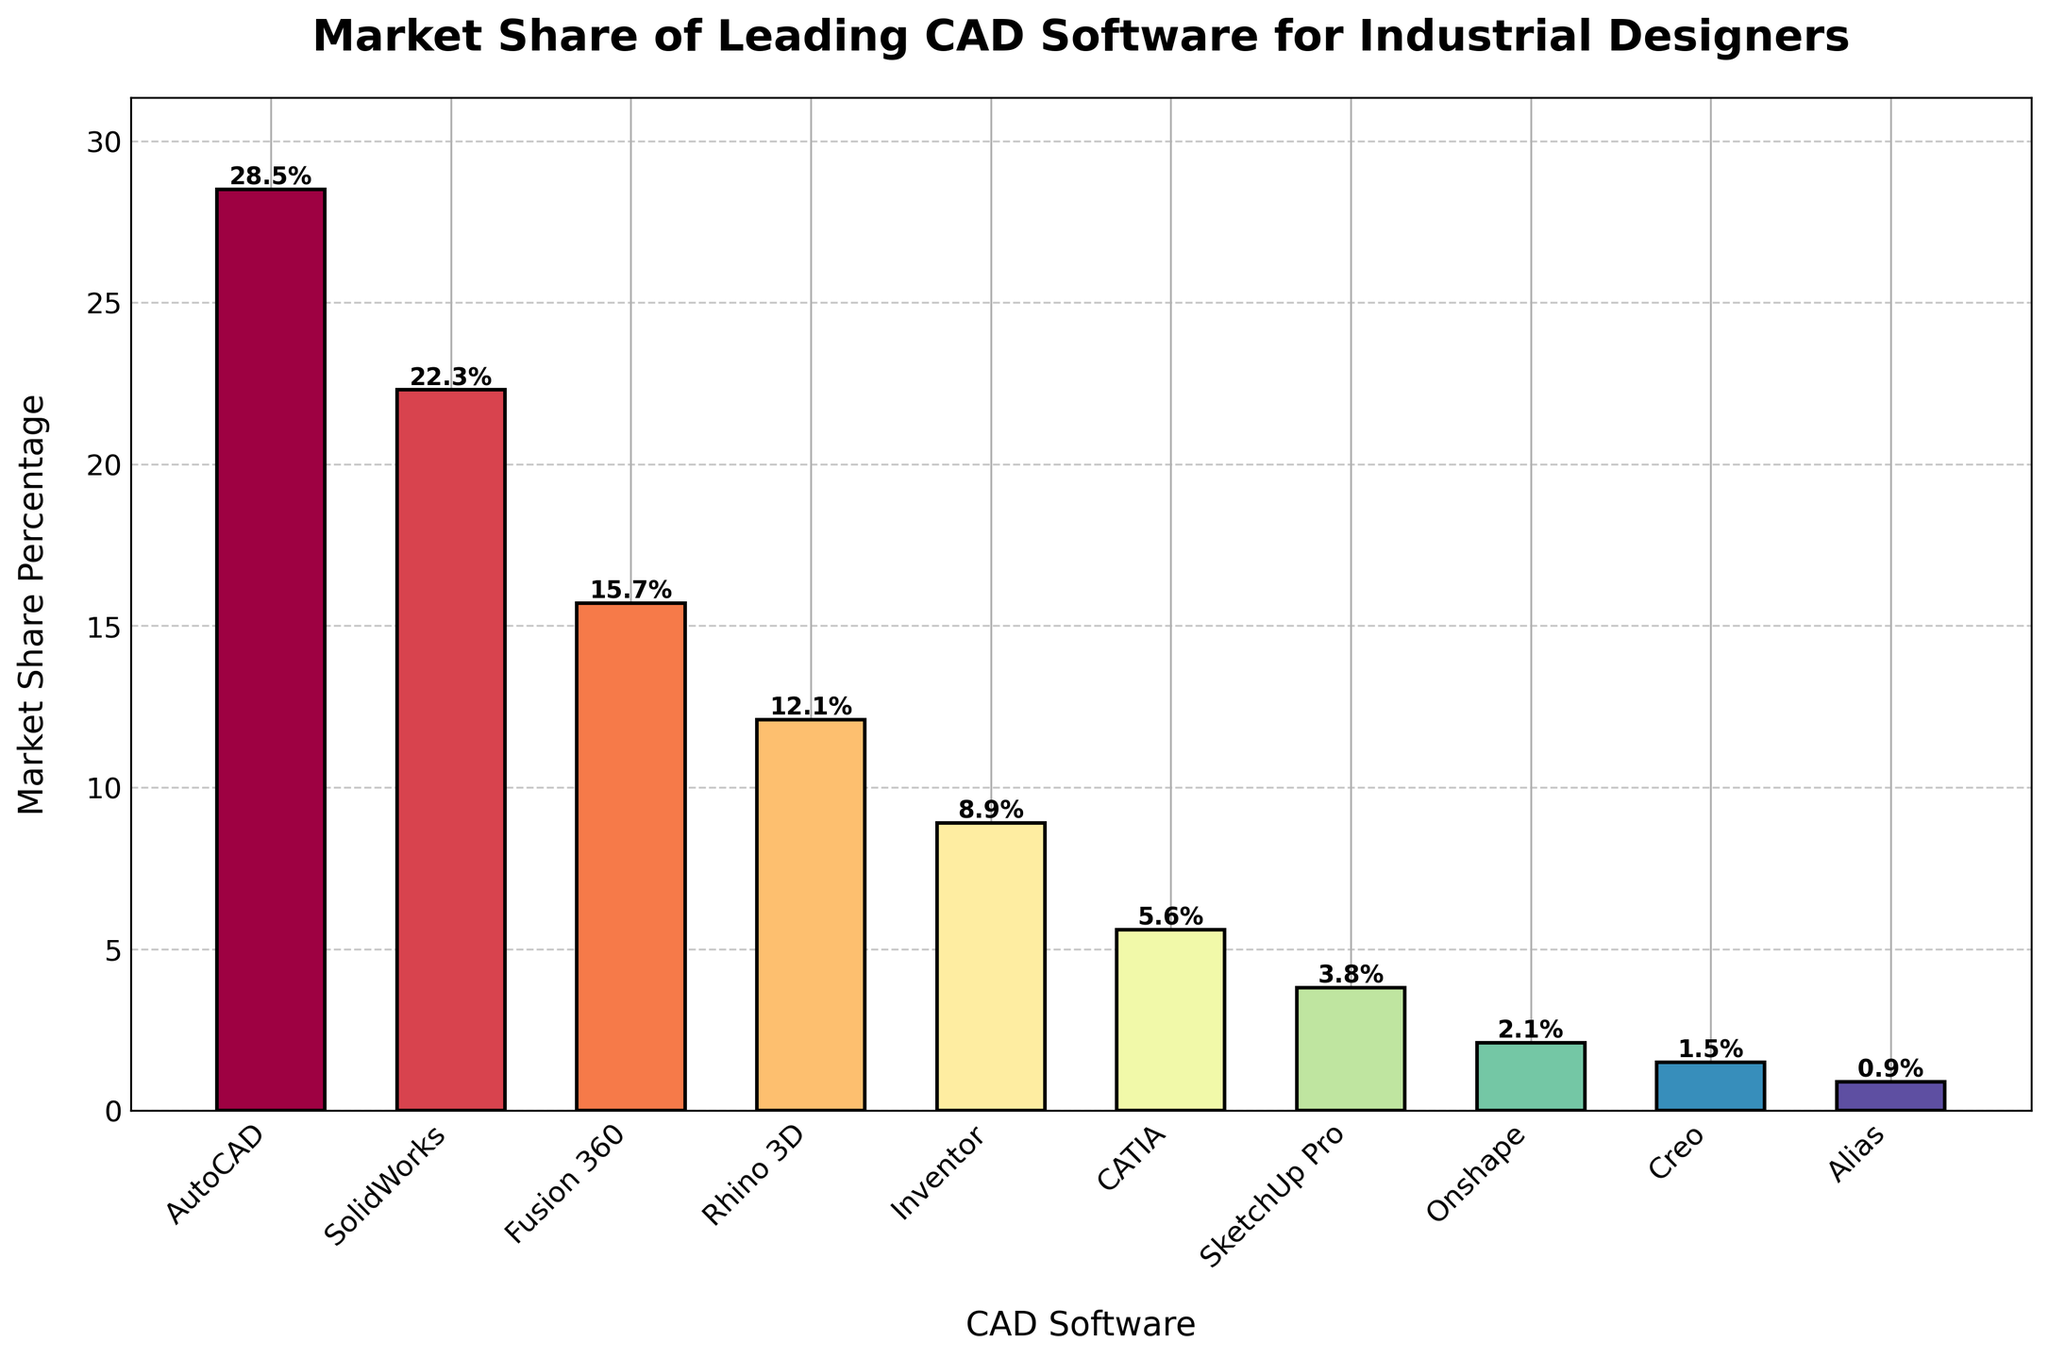What's the market share of the top-ranked CAD software? The top-ranked CAD software in the bar chart is AutoCAD. To find its market share, look at the height of the bar representing AutoCAD. The label on that bar indicates a market share of 28.5%.
Answer: 28.5% Which CAD software has a market share closest to 10%? From the bar chart, the software with a market share closest to 10% is Rhino 3D with a market share of 12.1%, and Inventor with a market share of 8.9%. Rhino 3D is closer to 10% than Inventor.
Answer: Rhino 3D What is the combined market share of the three leading CAD software? The three leading CAD software by market share are AutoCAD (28.5%), SolidWorks (22.3%), and Fusion 360 (15.7%). Add these percentages together: 28.5% + 22.3% + 15.7% = 66.5%.
Answer: 66.5% Which CAD software has the smallest market share? Looking at the smallest bar in the chart, the software with the smallest market share is Alias, which has a market share of 0.9%.
Answer: Alias What is the difference in market share between SolidWorks and Fusion 360? To find the difference, subtract the market share of Fusion 360 (15.7%) from that of SolidWorks (22.3%): 22.3% - 15.7% = 6.6%.
Answer: 6.6% How many CAD software have a market share greater than 10%? Count the bars with market share percentages greater than 10%. The software meeting this criterion are AutoCAD (28.5%), SolidWorks (22.3%), Fusion 360 (15.7%), and Rhino 3D (12.1%). There are 4 software.
Answer: 4 What is the average market share of all the CAD software listed? Calculate the average by summing the market shares: 28.5% + 22.3% + 15.7% + 12.1% + 8.9% + 5.6% + 3.8% + 2.1% + 1.5% + 0.9% = 101.4%, then divide by the number of software, which is 10: 101.4% / 10 = 10.14%.
Answer: 10.14% Which CAD software is represented by the tallest bar, and what does this visually indicate? The tallest bar in the chart represents AutoCAD, indicating it has the highest market share among the listed software at 28.5%.
Answer: AutoCAD By how much does the market share of Rhino 3D exceed that of Onshape? Subtract the market share of Onshape (2.1%) from that of Rhino 3D (12.1%): 12.1% - 2.1% = 10.0%.
Answer: 10.0% 